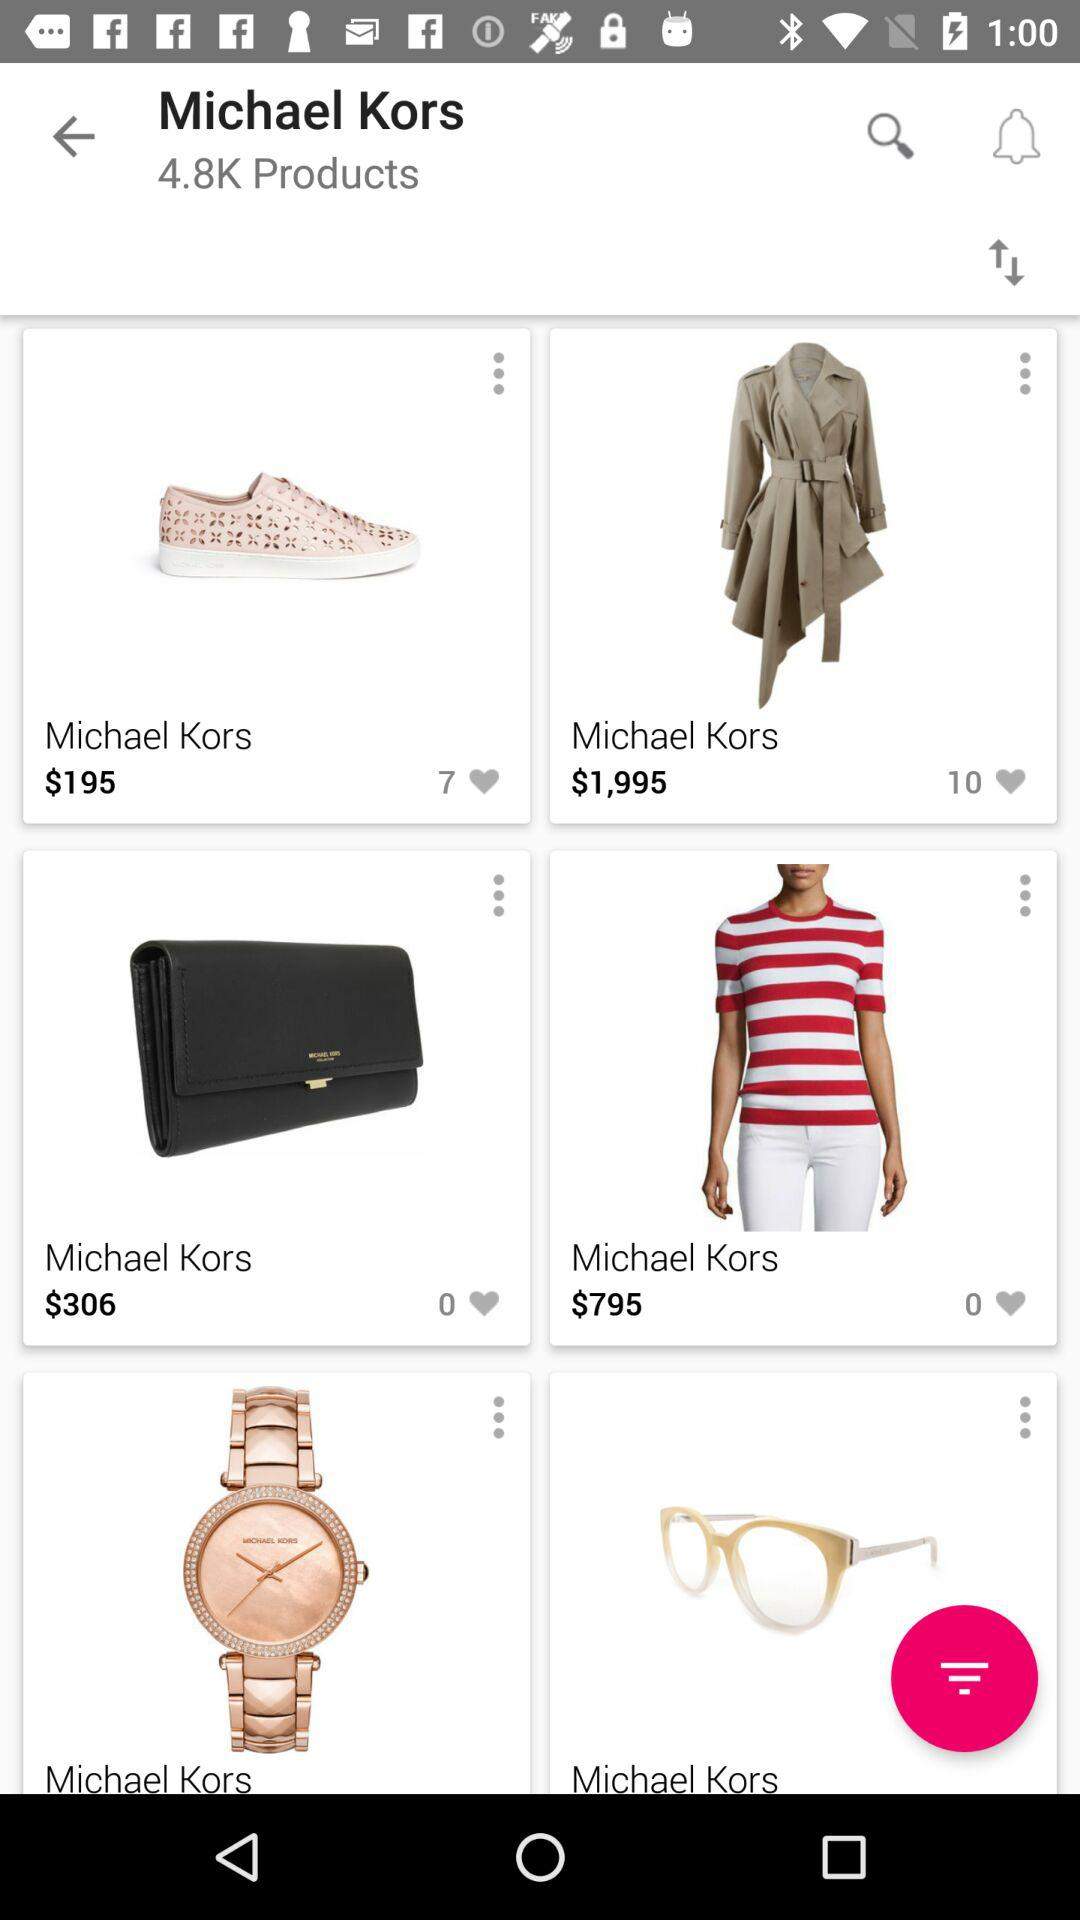How much does a coat cost? The cost of the coat is $1,995. 